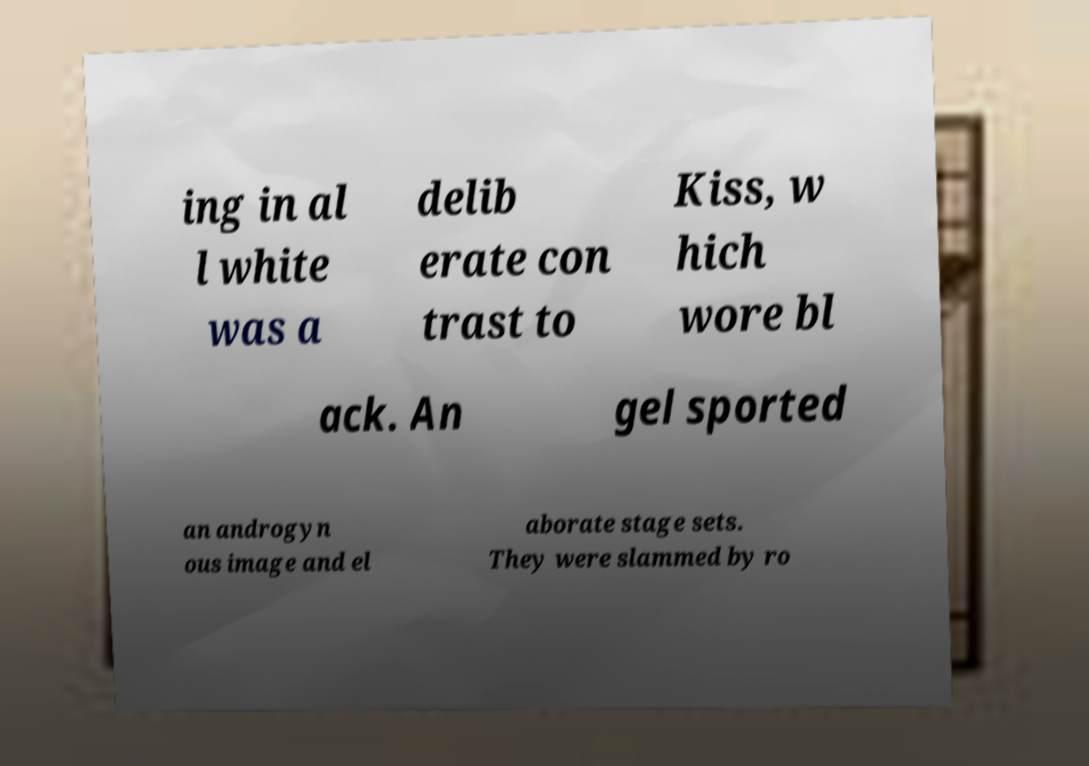Please read and relay the text visible in this image. What does it say? ing in al l white was a delib erate con trast to Kiss, w hich wore bl ack. An gel sported an androgyn ous image and el aborate stage sets. They were slammed by ro 